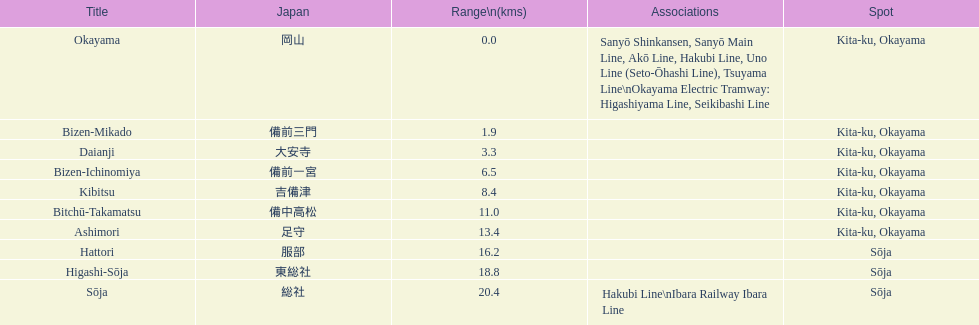Which has a distance of more than 1 kilometer but less than 2 kilometers? Bizen-Mikado. 